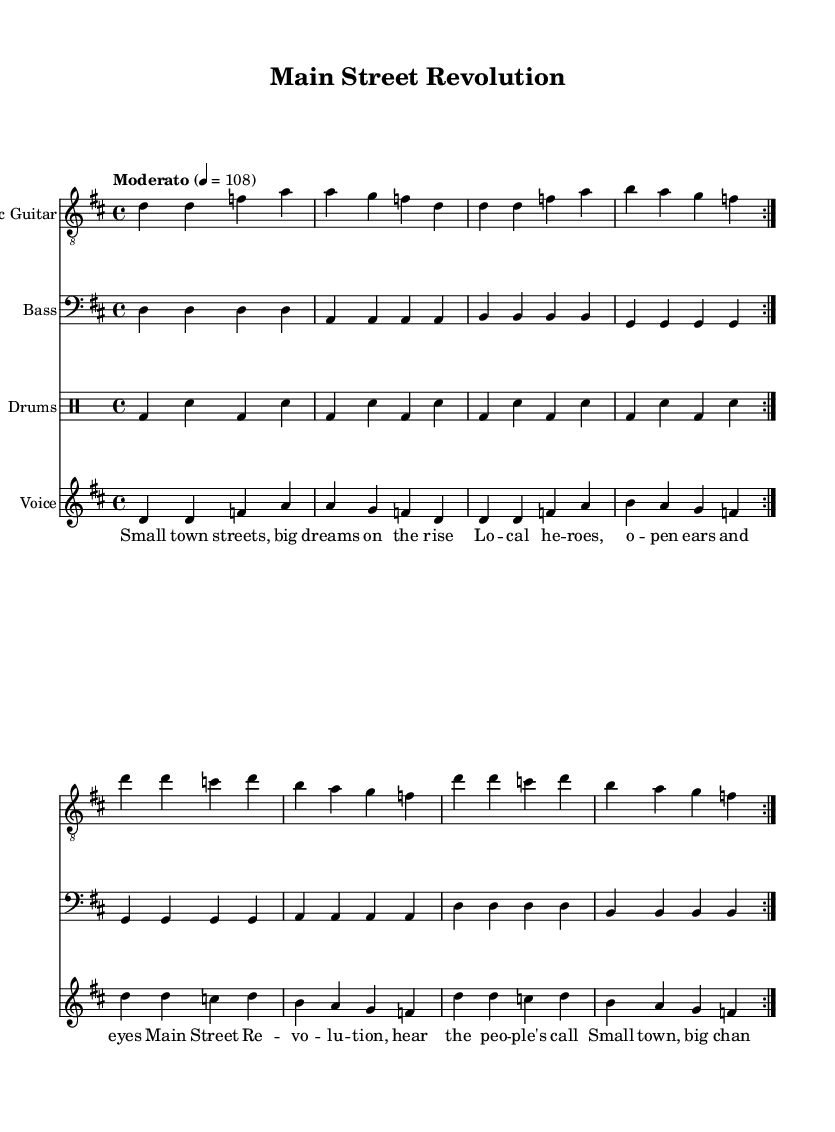What is the key signature of this music? The key signature is indicated at the beginning of the score. In this case, it shows two sharps, which correspond to D major.
Answer: D major What is the time signature of this music? The time signature can be found at the beginning of the score and is represented by the numbers 4 and 4, indicating that there are four beats per measure.
Answer: 4/4 What is the tempo marking for this piece? The tempo is given in beats per minute (BPM) and is located at the beginning of the score. Here, it is set to "Moderato" at 108 BPM.
Answer: Moderato, 108 How many verses are in the song? The score includes the repetition indication "volta 2" for both the verse and chorus sections, indicating they repeat twice. Thus, there are two verses.
Answer: 2 What is the main theme of the lyrics? The lyrics revolve around small-town activism and community development, emphasizing local heroes and calls for change, which reflects the influence of small-town politics.
Answer: Small-town activism What instruments are featured in this piece? The score lists various staves, specifically naming the Electric Guitar, Bass, Drums, and Voice, indicating these instruments are part of the performance.
Answer: Electric Guitar, Bass, Drums, Voice What style of music does this sheet represent? The combination of instruments, lyrics, and overall structure is commonly associated with rock music, particularly classic rock anthems that address social issues and community dynamics.
Answer: Classic rock 